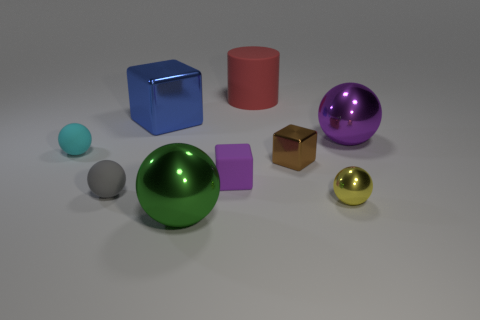Subtract all shiny blocks. How many blocks are left? 1 Subtract all blue cubes. How many cubes are left? 2 Subtract all blue blocks. How many cyan balls are left? 1 Subtract all tiny brown spheres. Subtract all small shiny objects. How many objects are left? 7 Add 8 large blue cubes. How many large blue cubes are left? 9 Add 6 large red metal spheres. How many large red metal spheres exist? 6 Subtract 0 red blocks. How many objects are left? 9 Subtract all balls. How many objects are left? 4 Subtract 1 cubes. How many cubes are left? 2 Subtract all cyan cubes. Subtract all cyan balls. How many cubes are left? 3 